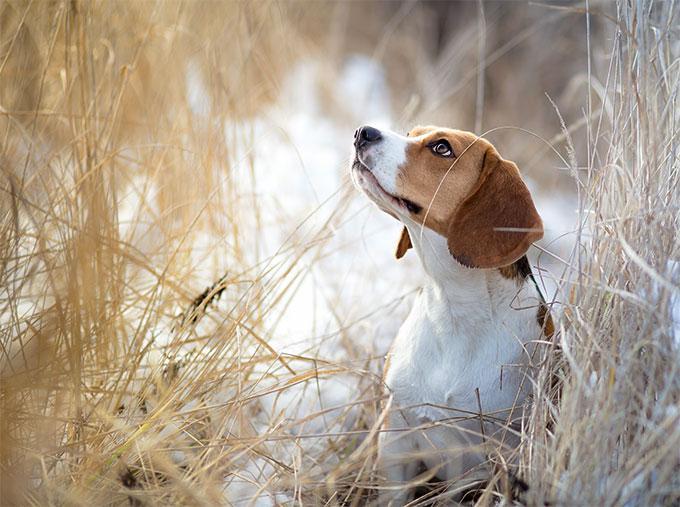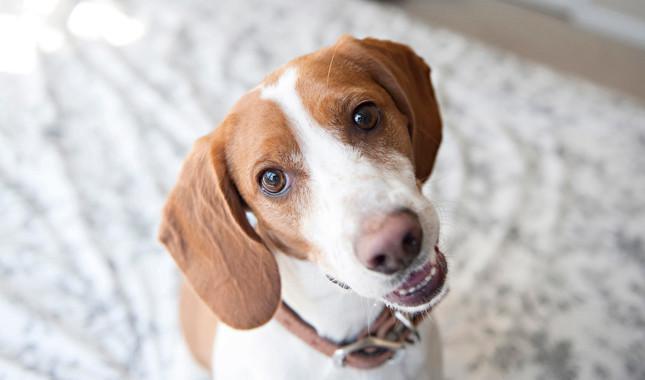The first image is the image on the left, the second image is the image on the right. For the images shown, is this caption "Each image shows exactly one beagle, and at least one beagle is looking at the camera." true? Answer yes or no. Yes. The first image is the image on the left, the second image is the image on the right. Examine the images to the left and right. Is the description "No image contains more than one beagle dog, and at least one dog looks directly at the camera." accurate? Answer yes or no. Yes. 